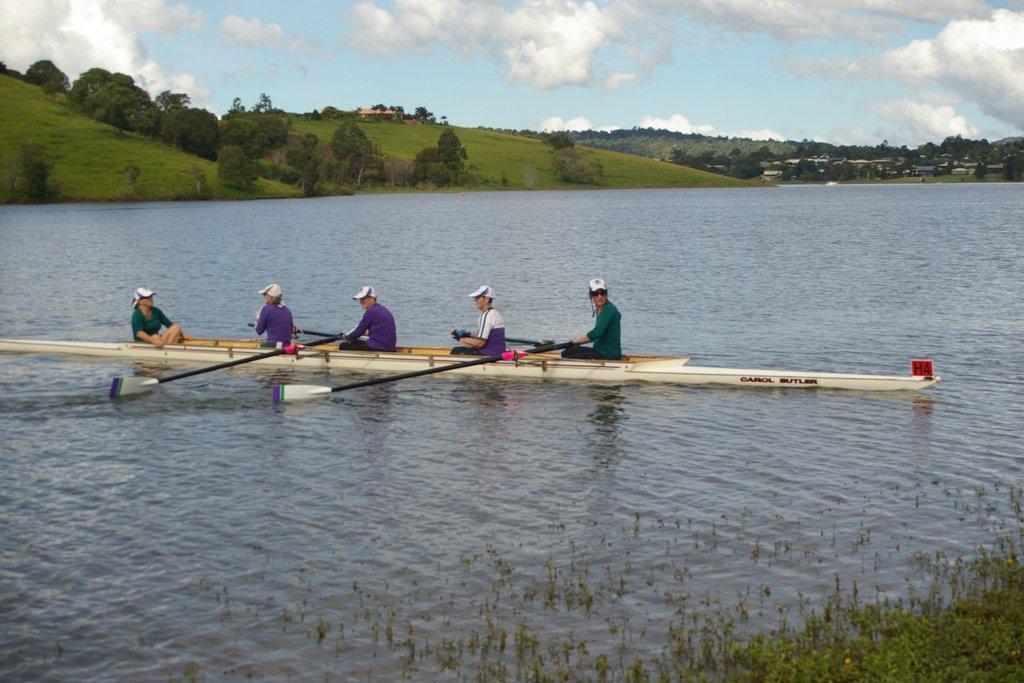Could you give a brief overview of what you see in this image? In this picture, we see four men and a woman are riding the sailboat. At the bottom of the picture, we see the grass and water. This water might be in the lake. There are trees and buildings in the background. At the top, we see the sky and the clouds. 